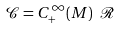Convert formula to latex. <formula><loc_0><loc_0><loc_500><loc_500>\mathcal { C } = C ^ { \infty } _ { + } ( M ) \ \mathcal { R }</formula> 